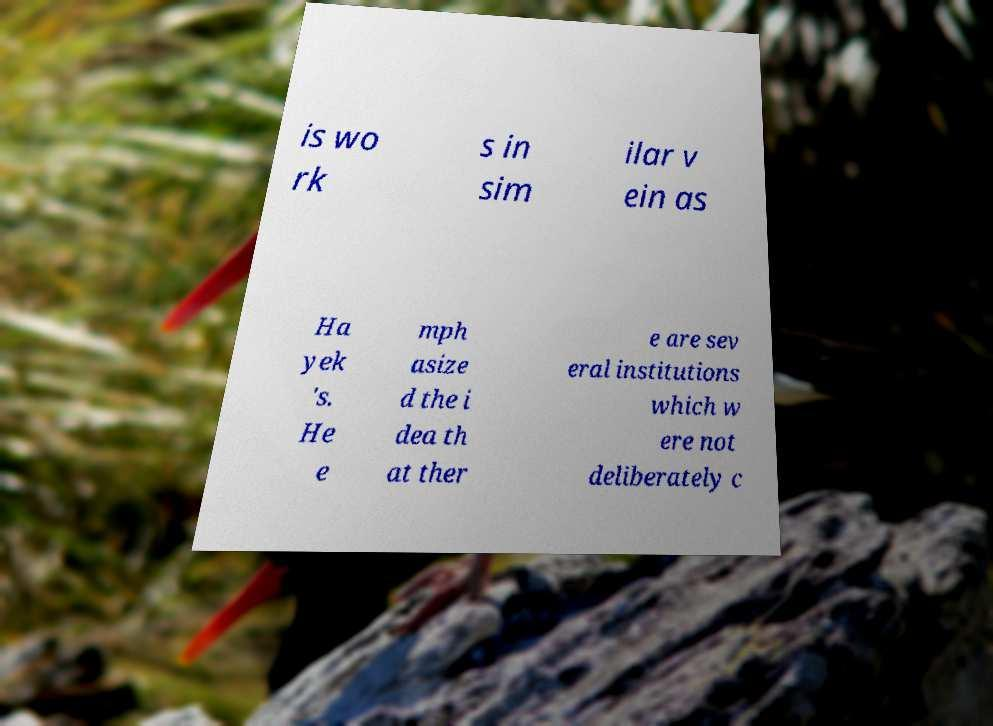There's text embedded in this image that I need extracted. Can you transcribe it verbatim? is wo rk s in sim ilar v ein as Ha yek 's. He e mph asize d the i dea th at ther e are sev eral institutions which w ere not deliberately c 